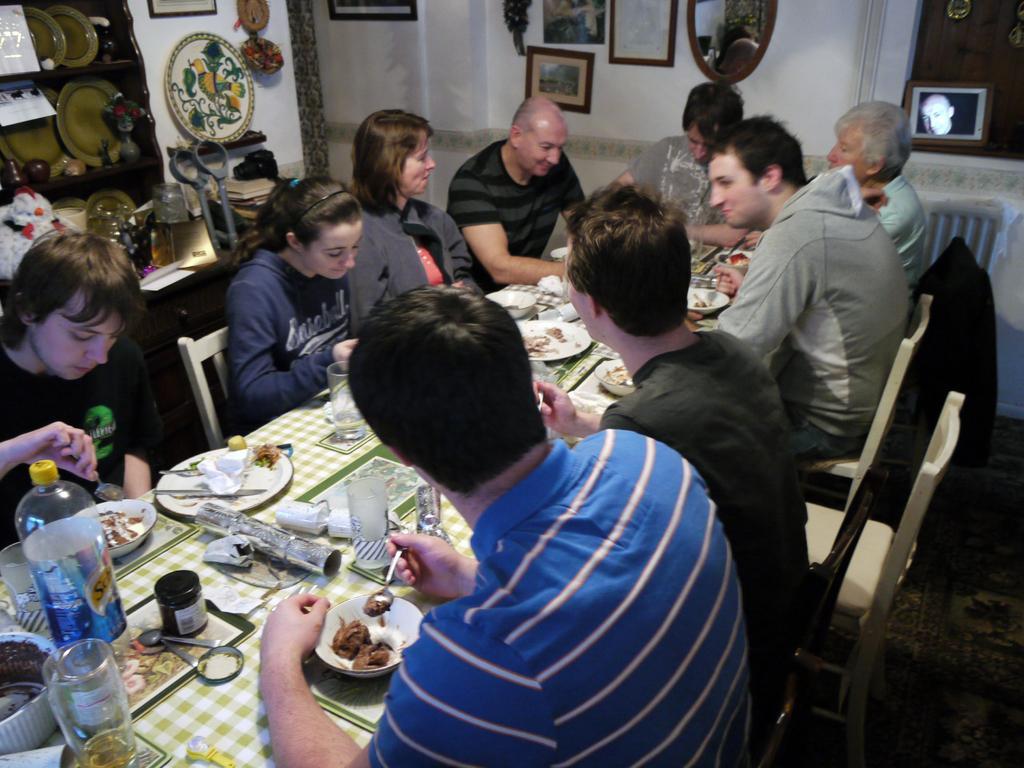Describe this image in one or two sentences. in this picture we can see a wall and a photo frame on it, and here are group of members sitting on a dining table and eating, there are many food items the table, bottles, glasses and many other objects ,and right to opposite there are many plates in the shelves. 